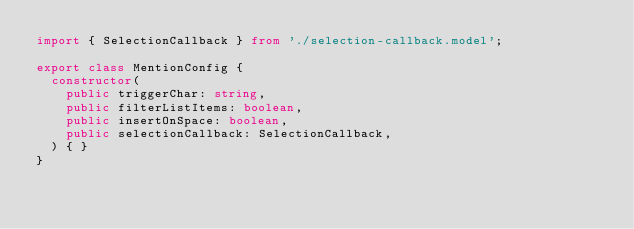Convert code to text. <code><loc_0><loc_0><loc_500><loc_500><_TypeScript_>import { SelectionCallback } from './selection-callback.model';

export class MentionConfig {
  constructor(
    public triggerChar: string,
    public filterListItems: boolean,
    public insertOnSpace: boolean,
    public selectionCallback: SelectionCallback,
  ) { }
}</code> 